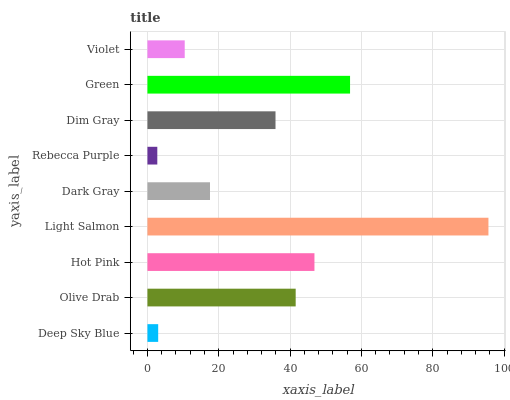Is Rebecca Purple the minimum?
Answer yes or no. Yes. Is Light Salmon the maximum?
Answer yes or no. Yes. Is Olive Drab the minimum?
Answer yes or no. No. Is Olive Drab the maximum?
Answer yes or no. No. Is Olive Drab greater than Deep Sky Blue?
Answer yes or no. Yes. Is Deep Sky Blue less than Olive Drab?
Answer yes or no. Yes. Is Deep Sky Blue greater than Olive Drab?
Answer yes or no. No. Is Olive Drab less than Deep Sky Blue?
Answer yes or no. No. Is Dim Gray the high median?
Answer yes or no. Yes. Is Dim Gray the low median?
Answer yes or no. Yes. Is Rebecca Purple the high median?
Answer yes or no. No. Is Dark Gray the low median?
Answer yes or no. No. 